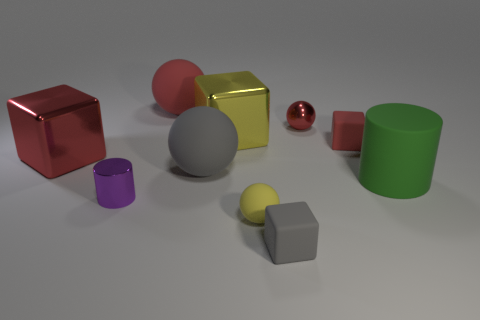What is the material of the tiny object that is the same color as the small metallic ball?
Keep it short and to the point. Rubber. What size is the ball in front of the purple shiny cylinder?
Your answer should be very brief. Small. Are there any cyan objects that have the same material as the yellow block?
Your answer should be very brief. No. Is the color of the small rubber thing that is behind the yellow sphere the same as the matte cylinder?
Provide a short and direct response. No. Is the number of purple metal cylinders that are behind the big green thing the same as the number of brown matte blocks?
Keep it short and to the point. Yes. Is there a metallic cube that has the same color as the small rubber sphere?
Provide a short and direct response. Yes. Do the gray block and the red shiny ball have the same size?
Your response must be concise. Yes. There is a metallic cube to the right of the red thing in front of the tiny red block; how big is it?
Your response must be concise. Large. There is a ball that is both in front of the red rubber ball and behind the red shiny block; what size is it?
Your answer should be very brief. Small. What number of red shiny objects have the same size as the yellow sphere?
Give a very brief answer. 1. 